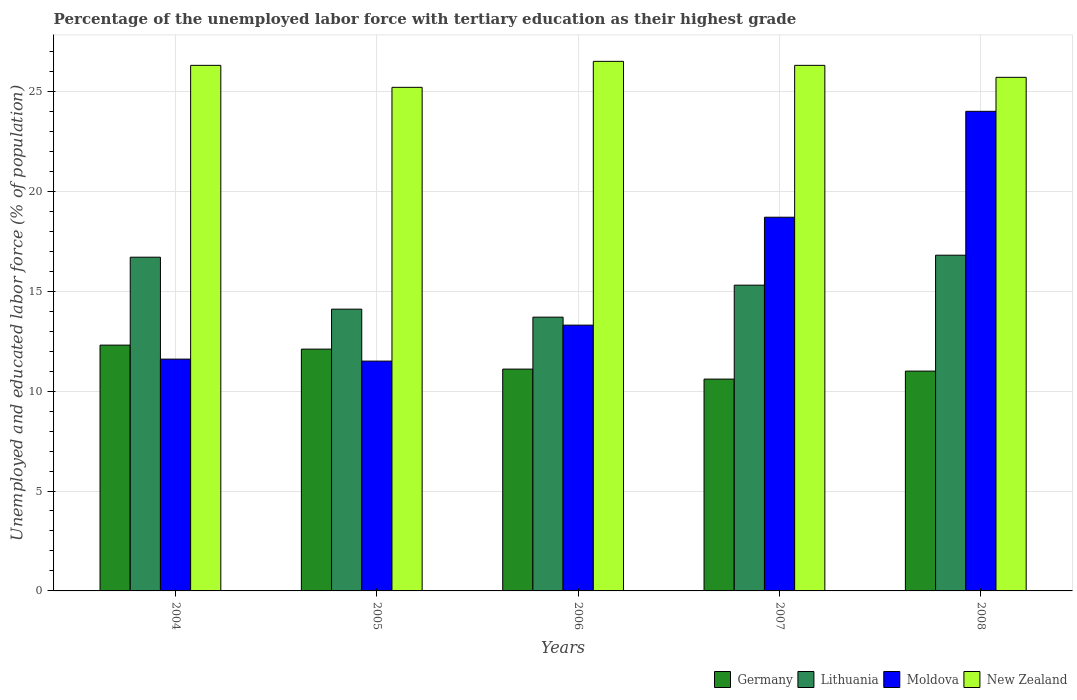Are the number of bars on each tick of the X-axis equal?
Your response must be concise. Yes. How many bars are there on the 5th tick from the left?
Keep it short and to the point. 4. What is the label of the 5th group of bars from the left?
Offer a terse response. 2008. What is the percentage of the unemployed labor force with tertiary education in New Zealand in 2004?
Provide a succinct answer. 26.3. Across all years, what is the maximum percentage of the unemployed labor force with tertiary education in Lithuania?
Give a very brief answer. 16.8. In which year was the percentage of the unemployed labor force with tertiary education in Germany maximum?
Offer a very short reply. 2004. In which year was the percentage of the unemployed labor force with tertiary education in Moldova minimum?
Your answer should be very brief. 2005. What is the total percentage of the unemployed labor force with tertiary education in New Zealand in the graph?
Offer a very short reply. 130. What is the difference between the percentage of the unemployed labor force with tertiary education in Lithuania in 2005 and that in 2006?
Provide a short and direct response. 0.4. What is the difference between the percentage of the unemployed labor force with tertiary education in Lithuania in 2007 and the percentage of the unemployed labor force with tertiary education in Germany in 2008?
Provide a succinct answer. 4.3. What is the average percentage of the unemployed labor force with tertiary education in Germany per year?
Your answer should be very brief. 11.42. In the year 2008, what is the difference between the percentage of the unemployed labor force with tertiary education in Lithuania and percentage of the unemployed labor force with tertiary education in Germany?
Provide a short and direct response. 5.8. In how many years, is the percentage of the unemployed labor force with tertiary education in New Zealand greater than 16 %?
Your response must be concise. 5. What is the ratio of the percentage of the unemployed labor force with tertiary education in Lithuania in 2004 to that in 2006?
Your answer should be compact. 1.22. What is the difference between the highest and the second highest percentage of the unemployed labor force with tertiary education in Lithuania?
Your response must be concise. 0.1. What is the difference between the highest and the lowest percentage of the unemployed labor force with tertiary education in Moldova?
Make the answer very short. 12.5. In how many years, is the percentage of the unemployed labor force with tertiary education in Germany greater than the average percentage of the unemployed labor force with tertiary education in Germany taken over all years?
Ensure brevity in your answer.  2. Is it the case that in every year, the sum of the percentage of the unemployed labor force with tertiary education in Lithuania and percentage of the unemployed labor force with tertiary education in New Zealand is greater than the sum of percentage of the unemployed labor force with tertiary education in Moldova and percentage of the unemployed labor force with tertiary education in Germany?
Your answer should be very brief. Yes. What does the 2nd bar from the left in 2007 represents?
Offer a terse response. Lithuania. What does the 1st bar from the right in 2008 represents?
Offer a very short reply. New Zealand. Is it the case that in every year, the sum of the percentage of the unemployed labor force with tertiary education in Germany and percentage of the unemployed labor force with tertiary education in Moldova is greater than the percentage of the unemployed labor force with tertiary education in New Zealand?
Keep it short and to the point. No. How many bars are there?
Make the answer very short. 20. What is the difference between two consecutive major ticks on the Y-axis?
Make the answer very short. 5. Where does the legend appear in the graph?
Provide a short and direct response. Bottom right. How are the legend labels stacked?
Offer a very short reply. Horizontal. What is the title of the graph?
Make the answer very short. Percentage of the unemployed labor force with tertiary education as their highest grade. Does "Kenya" appear as one of the legend labels in the graph?
Your answer should be compact. No. What is the label or title of the Y-axis?
Give a very brief answer. Unemployed and educated labor force (% of population). What is the Unemployed and educated labor force (% of population) in Germany in 2004?
Keep it short and to the point. 12.3. What is the Unemployed and educated labor force (% of population) of Lithuania in 2004?
Your answer should be very brief. 16.7. What is the Unemployed and educated labor force (% of population) of Moldova in 2004?
Provide a succinct answer. 11.6. What is the Unemployed and educated labor force (% of population) of New Zealand in 2004?
Your response must be concise. 26.3. What is the Unemployed and educated labor force (% of population) in Germany in 2005?
Give a very brief answer. 12.1. What is the Unemployed and educated labor force (% of population) in Lithuania in 2005?
Provide a succinct answer. 14.1. What is the Unemployed and educated labor force (% of population) of New Zealand in 2005?
Keep it short and to the point. 25.2. What is the Unemployed and educated labor force (% of population) in Germany in 2006?
Provide a short and direct response. 11.1. What is the Unemployed and educated labor force (% of population) in Lithuania in 2006?
Provide a succinct answer. 13.7. What is the Unemployed and educated labor force (% of population) of Moldova in 2006?
Your answer should be very brief. 13.3. What is the Unemployed and educated labor force (% of population) in New Zealand in 2006?
Your response must be concise. 26.5. What is the Unemployed and educated labor force (% of population) in Germany in 2007?
Ensure brevity in your answer.  10.6. What is the Unemployed and educated labor force (% of population) of Lithuania in 2007?
Your answer should be compact. 15.3. What is the Unemployed and educated labor force (% of population) in Moldova in 2007?
Ensure brevity in your answer.  18.7. What is the Unemployed and educated labor force (% of population) in New Zealand in 2007?
Offer a terse response. 26.3. What is the Unemployed and educated labor force (% of population) in Lithuania in 2008?
Your answer should be very brief. 16.8. What is the Unemployed and educated labor force (% of population) of Moldova in 2008?
Offer a very short reply. 24. What is the Unemployed and educated labor force (% of population) in New Zealand in 2008?
Offer a very short reply. 25.7. Across all years, what is the maximum Unemployed and educated labor force (% of population) of Germany?
Provide a succinct answer. 12.3. Across all years, what is the maximum Unemployed and educated labor force (% of population) in Lithuania?
Your answer should be very brief. 16.8. Across all years, what is the minimum Unemployed and educated labor force (% of population) of Germany?
Your answer should be compact. 10.6. Across all years, what is the minimum Unemployed and educated labor force (% of population) in Lithuania?
Provide a short and direct response. 13.7. Across all years, what is the minimum Unemployed and educated labor force (% of population) of New Zealand?
Offer a very short reply. 25.2. What is the total Unemployed and educated labor force (% of population) of Germany in the graph?
Give a very brief answer. 57.1. What is the total Unemployed and educated labor force (% of population) in Lithuania in the graph?
Give a very brief answer. 76.6. What is the total Unemployed and educated labor force (% of population) of Moldova in the graph?
Provide a short and direct response. 79.1. What is the total Unemployed and educated labor force (% of population) in New Zealand in the graph?
Offer a very short reply. 130. What is the difference between the Unemployed and educated labor force (% of population) in Moldova in 2004 and that in 2005?
Keep it short and to the point. 0.1. What is the difference between the Unemployed and educated labor force (% of population) in New Zealand in 2004 and that in 2005?
Your answer should be compact. 1.1. What is the difference between the Unemployed and educated labor force (% of population) of Lithuania in 2004 and that in 2006?
Keep it short and to the point. 3. What is the difference between the Unemployed and educated labor force (% of population) of Moldova in 2004 and that in 2006?
Offer a terse response. -1.7. What is the difference between the Unemployed and educated labor force (% of population) in New Zealand in 2004 and that in 2006?
Offer a very short reply. -0.2. What is the difference between the Unemployed and educated labor force (% of population) of Germany in 2004 and that in 2007?
Your answer should be compact. 1.7. What is the difference between the Unemployed and educated labor force (% of population) in Moldova in 2004 and that in 2007?
Ensure brevity in your answer.  -7.1. What is the difference between the Unemployed and educated labor force (% of population) in New Zealand in 2004 and that in 2007?
Your answer should be compact. 0. What is the difference between the Unemployed and educated labor force (% of population) in Lithuania in 2004 and that in 2008?
Ensure brevity in your answer.  -0.1. What is the difference between the Unemployed and educated labor force (% of population) in Moldova in 2005 and that in 2006?
Keep it short and to the point. -1.8. What is the difference between the Unemployed and educated labor force (% of population) of Lithuania in 2005 and that in 2007?
Your answer should be very brief. -1.2. What is the difference between the Unemployed and educated labor force (% of population) in Moldova in 2005 and that in 2007?
Your response must be concise. -7.2. What is the difference between the Unemployed and educated labor force (% of population) in Germany in 2005 and that in 2008?
Make the answer very short. 1.1. What is the difference between the Unemployed and educated labor force (% of population) in Moldova in 2005 and that in 2008?
Keep it short and to the point. -12.5. What is the difference between the Unemployed and educated labor force (% of population) of New Zealand in 2005 and that in 2008?
Your answer should be very brief. -0.5. What is the difference between the Unemployed and educated labor force (% of population) in Germany in 2006 and that in 2007?
Keep it short and to the point. 0.5. What is the difference between the Unemployed and educated labor force (% of population) of New Zealand in 2006 and that in 2007?
Keep it short and to the point. 0.2. What is the difference between the Unemployed and educated labor force (% of population) in Lithuania in 2006 and that in 2008?
Provide a succinct answer. -3.1. What is the difference between the Unemployed and educated labor force (% of population) of Germany in 2007 and that in 2008?
Offer a terse response. -0.4. What is the difference between the Unemployed and educated labor force (% of population) of Moldova in 2007 and that in 2008?
Provide a short and direct response. -5.3. What is the difference between the Unemployed and educated labor force (% of population) of Germany in 2004 and the Unemployed and educated labor force (% of population) of Lithuania in 2005?
Your answer should be very brief. -1.8. What is the difference between the Unemployed and educated labor force (% of population) in Germany in 2004 and the Unemployed and educated labor force (% of population) in Moldova in 2005?
Your answer should be very brief. 0.8. What is the difference between the Unemployed and educated labor force (% of population) in Germany in 2004 and the Unemployed and educated labor force (% of population) in New Zealand in 2005?
Provide a short and direct response. -12.9. What is the difference between the Unemployed and educated labor force (% of population) of Lithuania in 2004 and the Unemployed and educated labor force (% of population) of Moldova in 2005?
Provide a succinct answer. 5.2. What is the difference between the Unemployed and educated labor force (% of population) of Lithuania in 2004 and the Unemployed and educated labor force (% of population) of New Zealand in 2005?
Your answer should be compact. -8.5. What is the difference between the Unemployed and educated labor force (% of population) in Germany in 2004 and the Unemployed and educated labor force (% of population) in Moldova in 2006?
Ensure brevity in your answer.  -1. What is the difference between the Unemployed and educated labor force (% of population) of Germany in 2004 and the Unemployed and educated labor force (% of population) of New Zealand in 2006?
Provide a short and direct response. -14.2. What is the difference between the Unemployed and educated labor force (% of population) in Lithuania in 2004 and the Unemployed and educated labor force (% of population) in Moldova in 2006?
Your response must be concise. 3.4. What is the difference between the Unemployed and educated labor force (% of population) in Moldova in 2004 and the Unemployed and educated labor force (% of population) in New Zealand in 2006?
Make the answer very short. -14.9. What is the difference between the Unemployed and educated labor force (% of population) in Germany in 2004 and the Unemployed and educated labor force (% of population) in Lithuania in 2007?
Provide a succinct answer. -3. What is the difference between the Unemployed and educated labor force (% of population) in Lithuania in 2004 and the Unemployed and educated labor force (% of population) in Moldova in 2007?
Offer a very short reply. -2. What is the difference between the Unemployed and educated labor force (% of population) in Lithuania in 2004 and the Unemployed and educated labor force (% of population) in New Zealand in 2007?
Your answer should be very brief. -9.6. What is the difference between the Unemployed and educated labor force (% of population) of Moldova in 2004 and the Unemployed and educated labor force (% of population) of New Zealand in 2007?
Your response must be concise. -14.7. What is the difference between the Unemployed and educated labor force (% of population) in Germany in 2004 and the Unemployed and educated labor force (% of population) in Lithuania in 2008?
Offer a very short reply. -4.5. What is the difference between the Unemployed and educated labor force (% of population) of Germany in 2004 and the Unemployed and educated labor force (% of population) of Moldova in 2008?
Your answer should be compact. -11.7. What is the difference between the Unemployed and educated labor force (% of population) of Germany in 2004 and the Unemployed and educated labor force (% of population) of New Zealand in 2008?
Make the answer very short. -13.4. What is the difference between the Unemployed and educated labor force (% of population) of Lithuania in 2004 and the Unemployed and educated labor force (% of population) of New Zealand in 2008?
Provide a short and direct response. -9. What is the difference between the Unemployed and educated labor force (% of population) in Moldova in 2004 and the Unemployed and educated labor force (% of population) in New Zealand in 2008?
Provide a succinct answer. -14.1. What is the difference between the Unemployed and educated labor force (% of population) of Germany in 2005 and the Unemployed and educated labor force (% of population) of Moldova in 2006?
Provide a short and direct response. -1.2. What is the difference between the Unemployed and educated labor force (% of population) in Germany in 2005 and the Unemployed and educated labor force (% of population) in New Zealand in 2006?
Your response must be concise. -14.4. What is the difference between the Unemployed and educated labor force (% of population) in Germany in 2005 and the Unemployed and educated labor force (% of population) in Lithuania in 2007?
Provide a short and direct response. -3.2. What is the difference between the Unemployed and educated labor force (% of population) of Germany in 2005 and the Unemployed and educated labor force (% of population) of Moldova in 2007?
Offer a very short reply. -6.6. What is the difference between the Unemployed and educated labor force (% of population) in Germany in 2005 and the Unemployed and educated labor force (% of population) in New Zealand in 2007?
Keep it short and to the point. -14.2. What is the difference between the Unemployed and educated labor force (% of population) in Moldova in 2005 and the Unemployed and educated labor force (% of population) in New Zealand in 2007?
Keep it short and to the point. -14.8. What is the difference between the Unemployed and educated labor force (% of population) in Germany in 2005 and the Unemployed and educated labor force (% of population) in Lithuania in 2008?
Offer a terse response. -4.7. What is the difference between the Unemployed and educated labor force (% of population) of Germany in 2005 and the Unemployed and educated labor force (% of population) of New Zealand in 2008?
Your answer should be very brief. -13.6. What is the difference between the Unemployed and educated labor force (% of population) in Germany in 2006 and the Unemployed and educated labor force (% of population) in Moldova in 2007?
Ensure brevity in your answer.  -7.6. What is the difference between the Unemployed and educated labor force (% of population) in Germany in 2006 and the Unemployed and educated labor force (% of population) in New Zealand in 2007?
Offer a very short reply. -15.2. What is the difference between the Unemployed and educated labor force (% of population) in Lithuania in 2006 and the Unemployed and educated labor force (% of population) in New Zealand in 2007?
Ensure brevity in your answer.  -12.6. What is the difference between the Unemployed and educated labor force (% of population) in Moldova in 2006 and the Unemployed and educated labor force (% of population) in New Zealand in 2007?
Your answer should be compact. -13. What is the difference between the Unemployed and educated labor force (% of population) of Germany in 2006 and the Unemployed and educated labor force (% of population) of Moldova in 2008?
Ensure brevity in your answer.  -12.9. What is the difference between the Unemployed and educated labor force (% of population) of Germany in 2006 and the Unemployed and educated labor force (% of population) of New Zealand in 2008?
Keep it short and to the point. -14.6. What is the difference between the Unemployed and educated labor force (% of population) of Germany in 2007 and the Unemployed and educated labor force (% of population) of Lithuania in 2008?
Your response must be concise. -6.2. What is the difference between the Unemployed and educated labor force (% of population) of Germany in 2007 and the Unemployed and educated labor force (% of population) of Moldova in 2008?
Your answer should be compact. -13.4. What is the difference between the Unemployed and educated labor force (% of population) of Germany in 2007 and the Unemployed and educated labor force (% of population) of New Zealand in 2008?
Ensure brevity in your answer.  -15.1. What is the average Unemployed and educated labor force (% of population) in Germany per year?
Provide a short and direct response. 11.42. What is the average Unemployed and educated labor force (% of population) of Lithuania per year?
Offer a very short reply. 15.32. What is the average Unemployed and educated labor force (% of population) of Moldova per year?
Your answer should be compact. 15.82. What is the average Unemployed and educated labor force (% of population) in New Zealand per year?
Provide a succinct answer. 26. In the year 2004, what is the difference between the Unemployed and educated labor force (% of population) of Germany and Unemployed and educated labor force (% of population) of Lithuania?
Offer a terse response. -4.4. In the year 2004, what is the difference between the Unemployed and educated labor force (% of population) of Lithuania and Unemployed and educated labor force (% of population) of Moldova?
Your response must be concise. 5.1. In the year 2004, what is the difference between the Unemployed and educated labor force (% of population) of Moldova and Unemployed and educated labor force (% of population) of New Zealand?
Offer a terse response. -14.7. In the year 2005, what is the difference between the Unemployed and educated labor force (% of population) in Germany and Unemployed and educated labor force (% of population) in Lithuania?
Make the answer very short. -2. In the year 2005, what is the difference between the Unemployed and educated labor force (% of population) of Germany and Unemployed and educated labor force (% of population) of New Zealand?
Provide a succinct answer. -13.1. In the year 2005, what is the difference between the Unemployed and educated labor force (% of population) of Lithuania and Unemployed and educated labor force (% of population) of Moldova?
Offer a terse response. 2.6. In the year 2005, what is the difference between the Unemployed and educated labor force (% of population) of Lithuania and Unemployed and educated labor force (% of population) of New Zealand?
Your response must be concise. -11.1. In the year 2005, what is the difference between the Unemployed and educated labor force (% of population) of Moldova and Unemployed and educated labor force (% of population) of New Zealand?
Keep it short and to the point. -13.7. In the year 2006, what is the difference between the Unemployed and educated labor force (% of population) of Germany and Unemployed and educated labor force (% of population) of Moldova?
Provide a succinct answer. -2.2. In the year 2006, what is the difference between the Unemployed and educated labor force (% of population) in Germany and Unemployed and educated labor force (% of population) in New Zealand?
Provide a succinct answer. -15.4. In the year 2006, what is the difference between the Unemployed and educated labor force (% of population) in Moldova and Unemployed and educated labor force (% of population) in New Zealand?
Make the answer very short. -13.2. In the year 2007, what is the difference between the Unemployed and educated labor force (% of population) of Germany and Unemployed and educated labor force (% of population) of Lithuania?
Provide a short and direct response. -4.7. In the year 2007, what is the difference between the Unemployed and educated labor force (% of population) in Germany and Unemployed and educated labor force (% of population) in Moldova?
Give a very brief answer. -8.1. In the year 2007, what is the difference between the Unemployed and educated labor force (% of population) of Germany and Unemployed and educated labor force (% of population) of New Zealand?
Ensure brevity in your answer.  -15.7. In the year 2007, what is the difference between the Unemployed and educated labor force (% of population) of Lithuania and Unemployed and educated labor force (% of population) of Moldova?
Provide a succinct answer. -3.4. In the year 2007, what is the difference between the Unemployed and educated labor force (% of population) in Moldova and Unemployed and educated labor force (% of population) in New Zealand?
Give a very brief answer. -7.6. In the year 2008, what is the difference between the Unemployed and educated labor force (% of population) in Germany and Unemployed and educated labor force (% of population) in Lithuania?
Make the answer very short. -5.8. In the year 2008, what is the difference between the Unemployed and educated labor force (% of population) in Germany and Unemployed and educated labor force (% of population) in New Zealand?
Provide a succinct answer. -14.7. In the year 2008, what is the difference between the Unemployed and educated labor force (% of population) in Lithuania and Unemployed and educated labor force (% of population) in New Zealand?
Your answer should be very brief. -8.9. What is the ratio of the Unemployed and educated labor force (% of population) of Germany in 2004 to that in 2005?
Ensure brevity in your answer.  1.02. What is the ratio of the Unemployed and educated labor force (% of population) of Lithuania in 2004 to that in 2005?
Your answer should be very brief. 1.18. What is the ratio of the Unemployed and educated labor force (% of population) in Moldova in 2004 to that in 2005?
Ensure brevity in your answer.  1.01. What is the ratio of the Unemployed and educated labor force (% of population) of New Zealand in 2004 to that in 2005?
Provide a succinct answer. 1.04. What is the ratio of the Unemployed and educated labor force (% of population) of Germany in 2004 to that in 2006?
Give a very brief answer. 1.11. What is the ratio of the Unemployed and educated labor force (% of population) in Lithuania in 2004 to that in 2006?
Your response must be concise. 1.22. What is the ratio of the Unemployed and educated labor force (% of population) in Moldova in 2004 to that in 2006?
Give a very brief answer. 0.87. What is the ratio of the Unemployed and educated labor force (% of population) of New Zealand in 2004 to that in 2006?
Offer a very short reply. 0.99. What is the ratio of the Unemployed and educated labor force (% of population) in Germany in 2004 to that in 2007?
Your answer should be compact. 1.16. What is the ratio of the Unemployed and educated labor force (% of population) in Lithuania in 2004 to that in 2007?
Offer a very short reply. 1.09. What is the ratio of the Unemployed and educated labor force (% of population) in Moldova in 2004 to that in 2007?
Offer a very short reply. 0.62. What is the ratio of the Unemployed and educated labor force (% of population) of New Zealand in 2004 to that in 2007?
Give a very brief answer. 1. What is the ratio of the Unemployed and educated labor force (% of population) of Germany in 2004 to that in 2008?
Offer a very short reply. 1.12. What is the ratio of the Unemployed and educated labor force (% of population) of Moldova in 2004 to that in 2008?
Provide a short and direct response. 0.48. What is the ratio of the Unemployed and educated labor force (% of population) in New Zealand in 2004 to that in 2008?
Provide a short and direct response. 1.02. What is the ratio of the Unemployed and educated labor force (% of population) of Germany in 2005 to that in 2006?
Give a very brief answer. 1.09. What is the ratio of the Unemployed and educated labor force (% of population) of Lithuania in 2005 to that in 2006?
Ensure brevity in your answer.  1.03. What is the ratio of the Unemployed and educated labor force (% of population) in Moldova in 2005 to that in 2006?
Ensure brevity in your answer.  0.86. What is the ratio of the Unemployed and educated labor force (% of population) in New Zealand in 2005 to that in 2006?
Offer a very short reply. 0.95. What is the ratio of the Unemployed and educated labor force (% of population) of Germany in 2005 to that in 2007?
Your answer should be compact. 1.14. What is the ratio of the Unemployed and educated labor force (% of population) of Lithuania in 2005 to that in 2007?
Provide a succinct answer. 0.92. What is the ratio of the Unemployed and educated labor force (% of population) of Moldova in 2005 to that in 2007?
Ensure brevity in your answer.  0.61. What is the ratio of the Unemployed and educated labor force (% of population) in New Zealand in 2005 to that in 2007?
Your answer should be very brief. 0.96. What is the ratio of the Unemployed and educated labor force (% of population) in Lithuania in 2005 to that in 2008?
Your answer should be very brief. 0.84. What is the ratio of the Unemployed and educated labor force (% of population) in Moldova in 2005 to that in 2008?
Your answer should be compact. 0.48. What is the ratio of the Unemployed and educated labor force (% of population) of New Zealand in 2005 to that in 2008?
Your answer should be very brief. 0.98. What is the ratio of the Unemployed and educated labor force (% of population) of Germany in 2006 to that in 2007?
Give a very brief answer. 1.05. What is the ratio of the Unemployed and educated labor force (% of population) in Lithuania in 2006 to that in 2007?
Make the answer very short. 0.9. What is the ratio of the Unemployed and educated labor force (% of population) of Moldova in 2006 to that in 2007?
Offer a terse response. 0.71. What is the ratio of the Unemployed and educated labor force (% of population) in New Zealand in 2006 to that in 2007?
Make the answer very short. 1.01. What is the ratio of the Unemployed and educated labor force (% of population) in Germany in 2006 to that in 2008?
Offer a terse response. 1.01. What is the ratio of the Unemployed and educated labor force (% of population) of Lithuania in 2006 to that in 2008?
Give a very brief answer. 0.82. What is the ratio of the Unemployed and educated labor force (% of population) of Moldova in 2006 to that in 2008?
Offer a very short reply. 0.55. What is the ratio of the Unemployed and educated labor force (% of population) in New Zealand in 2006 to that in 2008?
Your answer should be very brief. 1.03. What is the ratio of the Unemployed and educated labor force (% of population) in Germany in 2007 to that in 2008?
Make the answer very short. 0.96. What is the ratio of the Unemployed and educated labor force (% of population) of Lithuania in 2007 to that in 2008?
Give a very brief answer. 0.91. What is the ratio of the Unemployed and educated labor force (% of population) in Moldova in 2007 to that in 2008?
Provide a short and direct response. 0.78. What is the ratio of the Unemployed and educated labor force (% of population) in New Zealand in 2007 to that in 2008?
Offer a terse response. 1.02. What is the difference between the highest and the lowest Unemployed and educated labor force (% of population) in Germany?
Your answer should be very brief. 1.7. What is the difference between the highest and the lowest Unemployed and educated labor force (% of population) of Lithuania?
Provide a succinct answer. 3.1. What is the difference between the highest and the lowest Unemployed and educated labor force (% of population) in Moldova?
Make the answer very short. 12.5. What is the difference between the highest and the lowest Unemployed and educated labor force (% of population) in New Zealand?
Ensure brevity in your answer.  1.3. 